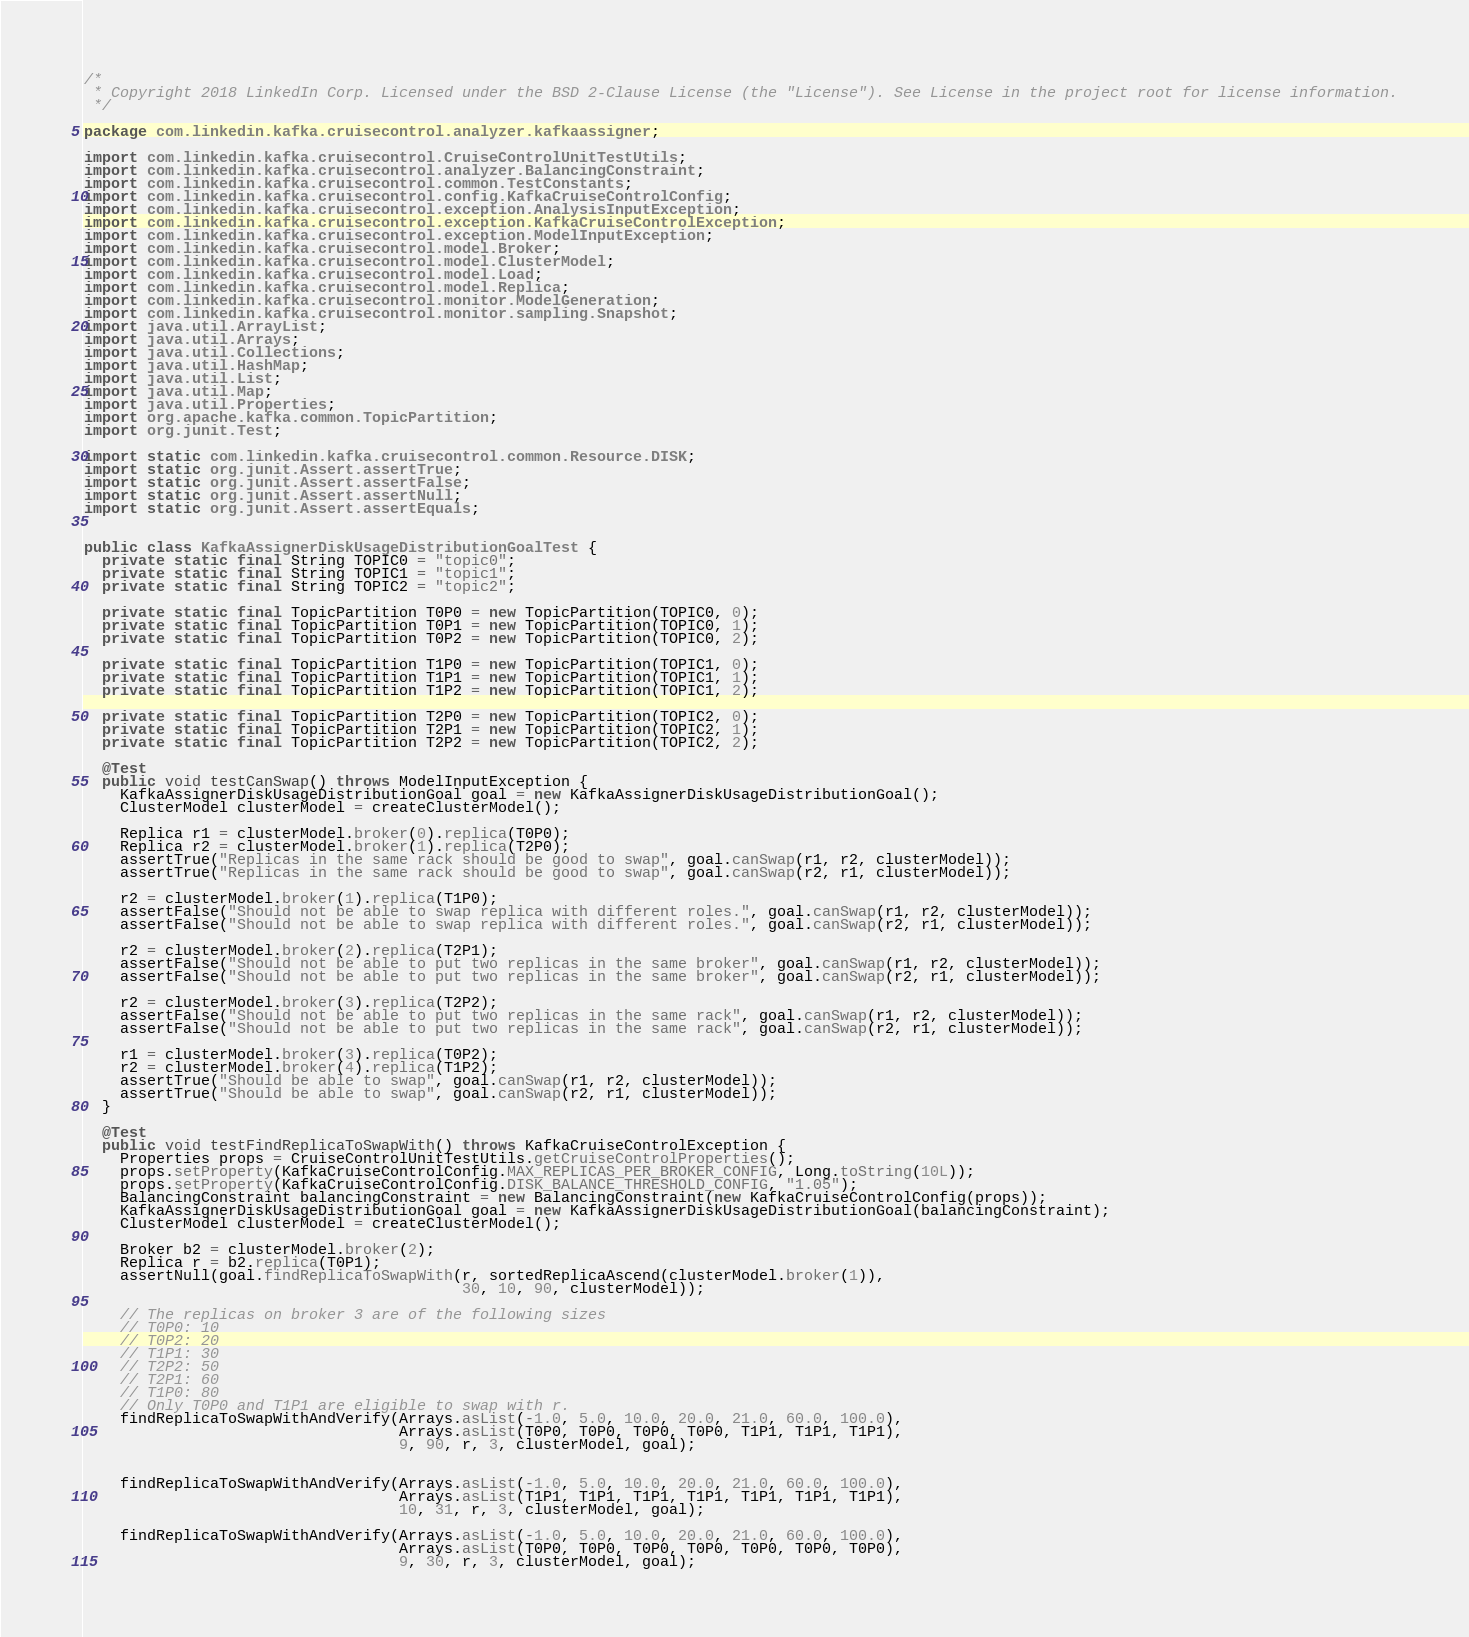Convert code to text. <code><loc_0><loc_0><loc_500><loc_500><_Java_>/*
 * Copyright 2018 LinkedIn Corp. Licensed under the BSD 2-Clause License (the "License"). See License in the project root for license information.
 */

package com.linkedin.kafka.cruisecontrol.analyzer.kafkaassigner;

import com.linkedin.kafka.cruisecontrol.CruiseControlUnitTestUtils;
import com.linkedin.kafka.cruisecontrol.analyzer.BalancingConstraint;
import com.linkedin.kafka.cruisecontrol.common.TestConstants;
import com.linkedin.kafka.cruisecontrol.config.KafkaCruiseControlConfig;
import com.linkedin.kafka.cruisecontrol.exception.AnalysisInputException;
import com.linkedin.kafka.cruisecontrol.exception.KafkaCruiseControlException;
import com.linkedin.kafka.cruisecontrol.exception.ModelInputException;
import com.linkedin.kafka.cruisecontrol.model.Broker;
import com.linkedin.kafka.cruisecontrol.model.ClusterModel;
import com.linkedin.kafka.cruisecontrol.model.Load;
import com.linkedin.kafka.cruisecontrol.model.Replica;
import com.linkedin.kafka.cruisecontrol.monitor.ModelGeneration;
import com.linkedin.kafka.cruisecontrol.monitor.sampling.Snapshot;
import java.util.ArrayList;
import java.util.Arrays;
import java.util.Collections;
import java.util.HashMap;
import java.util.List;
import java.util.Map;
import java.util.Properties;
import org.apache.kafka.common.TopicPartition;
import org.junit.Test;

import static com.linkedin.kafka.cruisecontrol.common.Resource.DISK;
import static org.junit.Assert.assertTrue;
import static org.junit.Assert.assertFalse;
import static org.junit.Assert.assertNull;
import static org.junit.Assert.assertEquals;


public class KafkaAssignerDiskUsageDistributionGoalTest {
  private static final String TOPIC0 = "topic0";
  private static final String TOPIC1 = "topic1";
  private static final String TOPIC2 = "topic2";

  private static final TopicPartition T0P0 = new TopicPartition(TOPIC0, 0);
  private static final TopicPartition T0P1 = new TopicPartition(TOPIC0, 1);
  private static final TopicPartition T0P2 = new TopicPartition(TOPIC0, 2);

  private static final TopicPartition T1P0 = new TopicPartition(TOPIC1, 0);
  private static final TopicPartition T1P1 = new TopicPartition(TOPIC1, 1);
  private static final TopicPartition T1P2 = new TopicPartition(TOPIC1, 2);

  private static final TopicPartition T2P0 = new TopicPartition(TOPIC2, 0);
  private static final TopicPartition T2P1 = new TopicPartition(TOPIC2, 1);
  private static final TopicPartition T2P2 = new TopicPartition(TOPIC2, 2);

  @Test
  public void testCanSwap() throws ModelInputException {
    KafkaAssignerDiskUsageDistributionGoal goal = new KafkaAssignerDiskUsageDistributionGoal();
    ClusterModel clusterModel = createClusterModel();

    Replica r1 = clusterModel.broker(0).replica(T0P0);
    Replica r2 = clusterModel.broker(1).replica(T2P0);
    assertTrue("Replicas in the same rack should be good to swap", goal.canSwap(r1, r2, clusterModel));
    assertTrue("Replicas in the same rack should be good to swap", goal.canSwap(r2, r1, clusterModel));

    r2 = clusterModel.broker(1).replica(T1P0);
    assertFalse("Should not be able to swap replica with different roles.", goal.canSwap(r1, r2, clusterModel));
    assertFalse("Should not be able to swap replica with different roles.", goal.canSwap(r2, r1, clusterModel));

    r2 = clusterModel.broker(2).replica(T2P1);
    assertFalse("Should not be able to put two replicas in the same broker", goal.canSwap(r1, r2, clusterModel));
    assertFalse("Should not be able to put two replicas in the same broker", goal.canSwap(r2, r1, clusterModel));

    r2 = clusterModel.broker(3).replica(T2P2);
    assertFalse("Should not be able to put two replicas in the same rack", goal.canSwap(r1, r2, clusterModel));
    assertFalse("Should not be able to put two replicas in the same rack", goal.canSwap(r2, r1, clusterModel));

    r1 = clusterModel.broker(3).replica(T0P2);
    r2 = clusterModel.broker(4).replica(T1P2);
    assertTrue("Should be able to swap", goal.canSwap(r1, r2, clusterModel));
    assertTrue("Should be able to swap", goal.canSwap(r2, r1, clusterModel));
  }

  @Test
  public void testFindReplicaToSwapWith() throws KafkaCruiseControlException {
    Properties props = CruiseControlUnitTestUtils.getCruiseControlProperties();
    props.setProperty(KafkaCruiseControlConfig.MAX_REPLICAS_PER_BROKER_CONFIG, Long.toString(10L));
    props.setProperty(KafkaCruiseControlConfig.DISK_BALANCE_THRESHOLD_CONFIG, "1.05");
    BalancingConstraint balancingConstraint = new BalancingConstraint(new KafkaCruiseControlConfig(props));
    KafkaAssignerDiskUsageDistributionGoal goal = new KafkaAssignerDiskUsageDistributionGoal(balancingConstraint);
    ClusterModel clusterModel = createClusterModel();

    Broker b2 = clusterModel.broker(2);
    Replica r = b2.replica(T0P1);
    assertNull(goal.findReplicaToSwapWith(r, sortedReplicaAscend(clusterModel.broker(1)),
                                          30, 10, 90, clusterModel));

    // The replicas on broker 3 are of the following sizes
    // T0P0: 10
    // T0P2: 20
    // T1P1: 30
    // T2P2: 50
    // T2P1: 60
    // T1P0: 80
    // Only T0P0 and T1P1 are eligible to swap with r.
    findReplicaToSwapWithAndVerify(Arrays.asList(-1.0, 5.0, 10.0, 20.0, 21.0, 60.0, 100.0),
                                   Arrays.asList(T0P0, T0P0, T0P0, T0P0, T1P1, T1P1, T1P1),
                                   9, 90, r, 3, clusterModel, goal);


    findReplicaToSwapWithAndVerify(Arrays.asList(-1.0, 5.0, 10.0, 20.0, 21.0, 60.0, 100.0),
                                   Arrays.asList(T1P1, T1P1, T1P1, T1P1, T1P1, T1P1, T1P1),
                                   10, 31, r, 3, clusterModel, goal);

    findReplicaToSwapWithAndVerify(Arrays.asList(-1.0, 5.0, 10.0, 20.0, 21.0, 60.0, 100.0),
                                   Arrays.asList(T0P0, T0P0, T0P0, T0P0, T0P0, T0P0, T0P0),
                                   9, 30, r, 3, clusterModel, goal);
</code> 